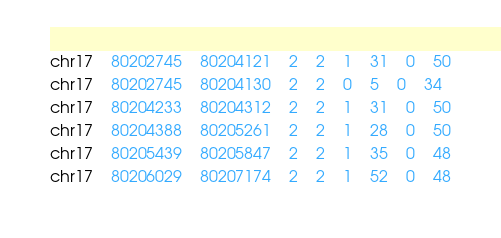<code> <loc_0><loc_0><loc_500><loc_500><_SQL_>chr17	80202745	80204121	2	2	1	31	0	50
chr17	80202745	80204130	2	2	0	5	0	34
chr17	80204233	80204312	2	2	1	31	0	50
chr17	80204388	80205261	2	2	1	28	0	50
chr17	80205439	80205847	2	2	1	35	0	48
chr17	80206029	80207174	2	2	1	52	0	48</code> 